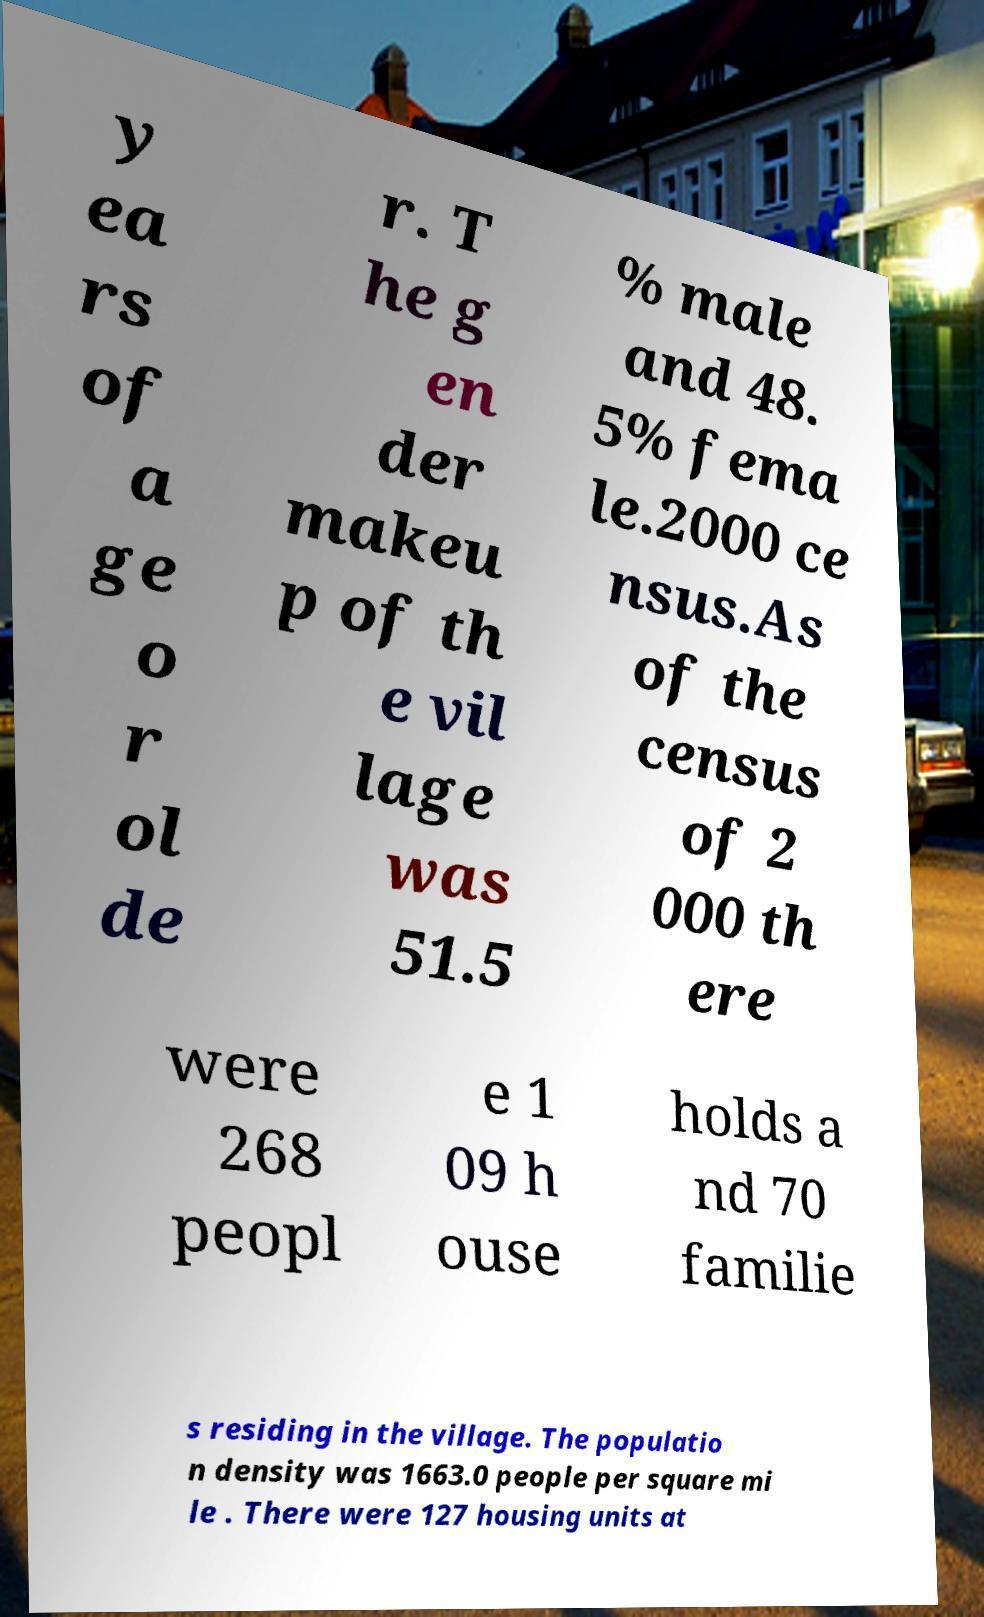Please read and relay the text visible in this image. What does it say? y ea rs of a ge o r ol de r. T he g en der makeu p of th e vil lage was 51.5 % male and 48. 5% fema le.2000 ce nsus.As of the census of 2 000 th ere were 268 peopl e 1 09 h ouse holds a nd 70 familie s residing in the village. The populatio n density was 1663.0 people per square mi le . There were 127 housing units at 